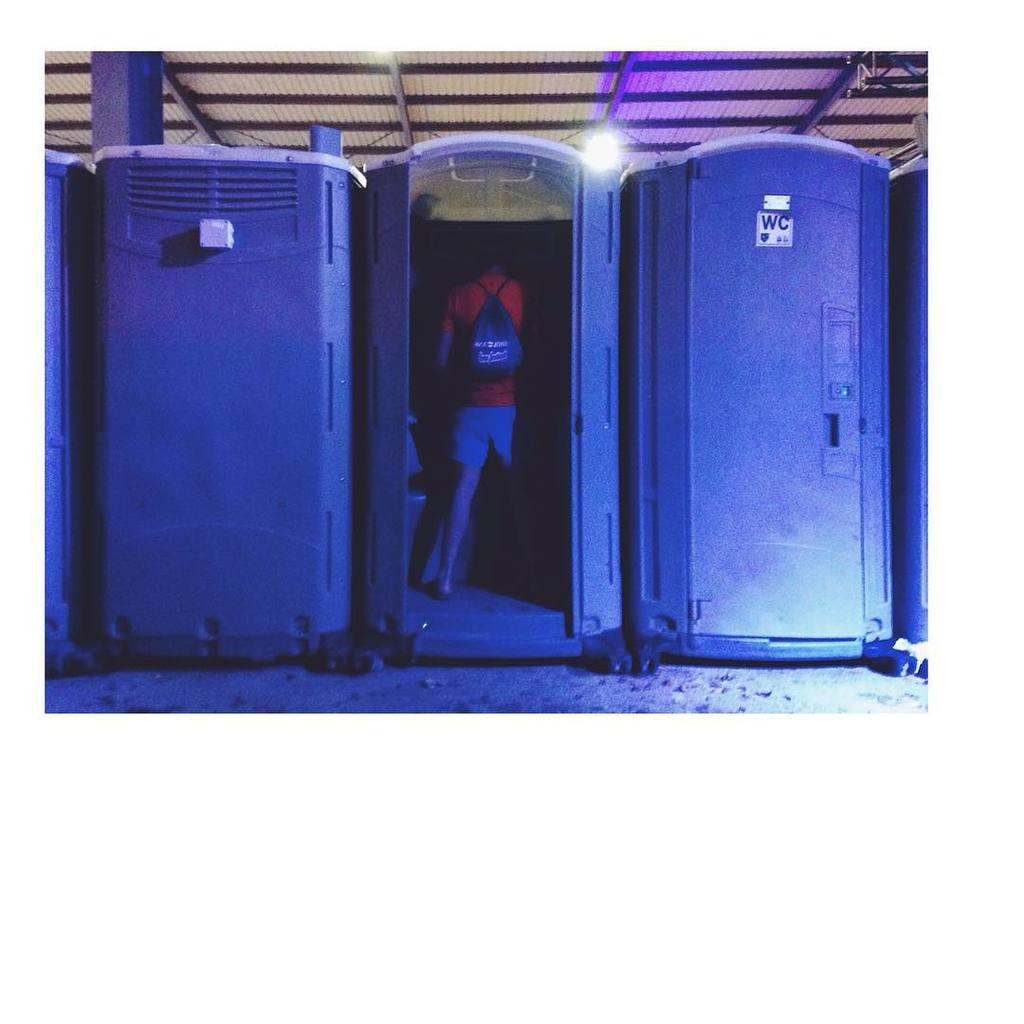How many public toilets are visible in the image? There are three public toilets in the image. Can you describe the person in the image? There is a man wearing a red t-shirt in the image. What is the man carrying in the image? The man is carrying a bag. What structure can be seen with rods in the image? There is a shed with rods in the image. What channel is the man watching on the television in the image? There is no television present in the image; it only features public toilets, a man wearing a red t-shirt, a bag, and a shed with rods. Is the man's father present in the image? There is no mention of the man's father in the image or the provided facts. 